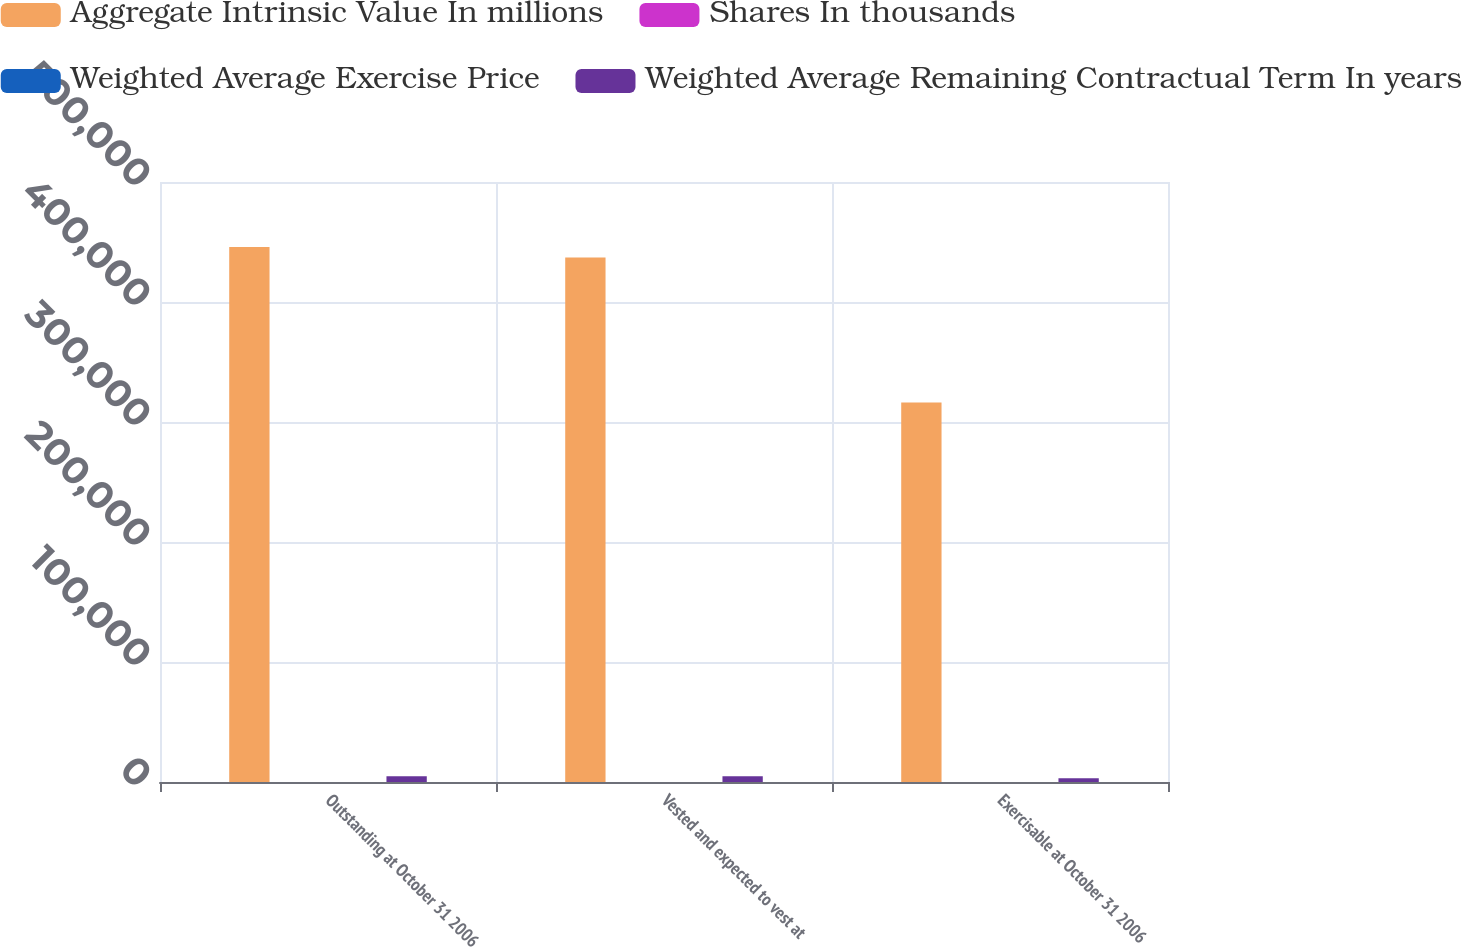<chart> <loc_0><loc_0><loc_500><loc_500><stacked_bar_chart><ecel><fcel>Outstanding at October 31 2006<fcel>Vested and expected to vest at<fcel>Exercisable at October 31 2006<nl><fcel>Aggregate Intrinsic Value In millions<fcel>445740<fcel>437109<fcel>316341<nl><fcel>Shares In thousands<fcel>31<fcel>31<fcel>33<nl><fcel>Weighted Average Exercise Price<fcel>4.7<fcel>4.6<fcel>4<nl><fcel>Weighted Average Remaining Contractual Term In years<fcel>4861<fcel>4742<fcel>3081<nl></chart> 